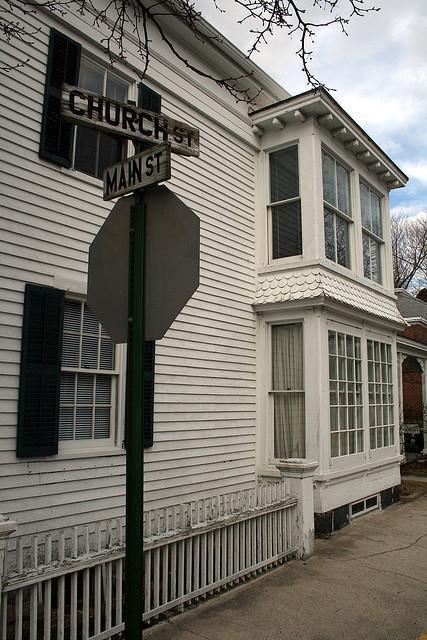How many stories in the house?
Give a very brief answer. 2. 